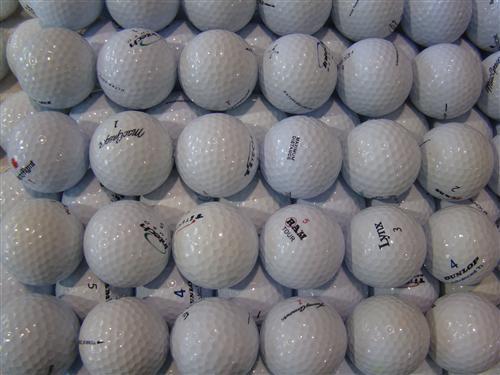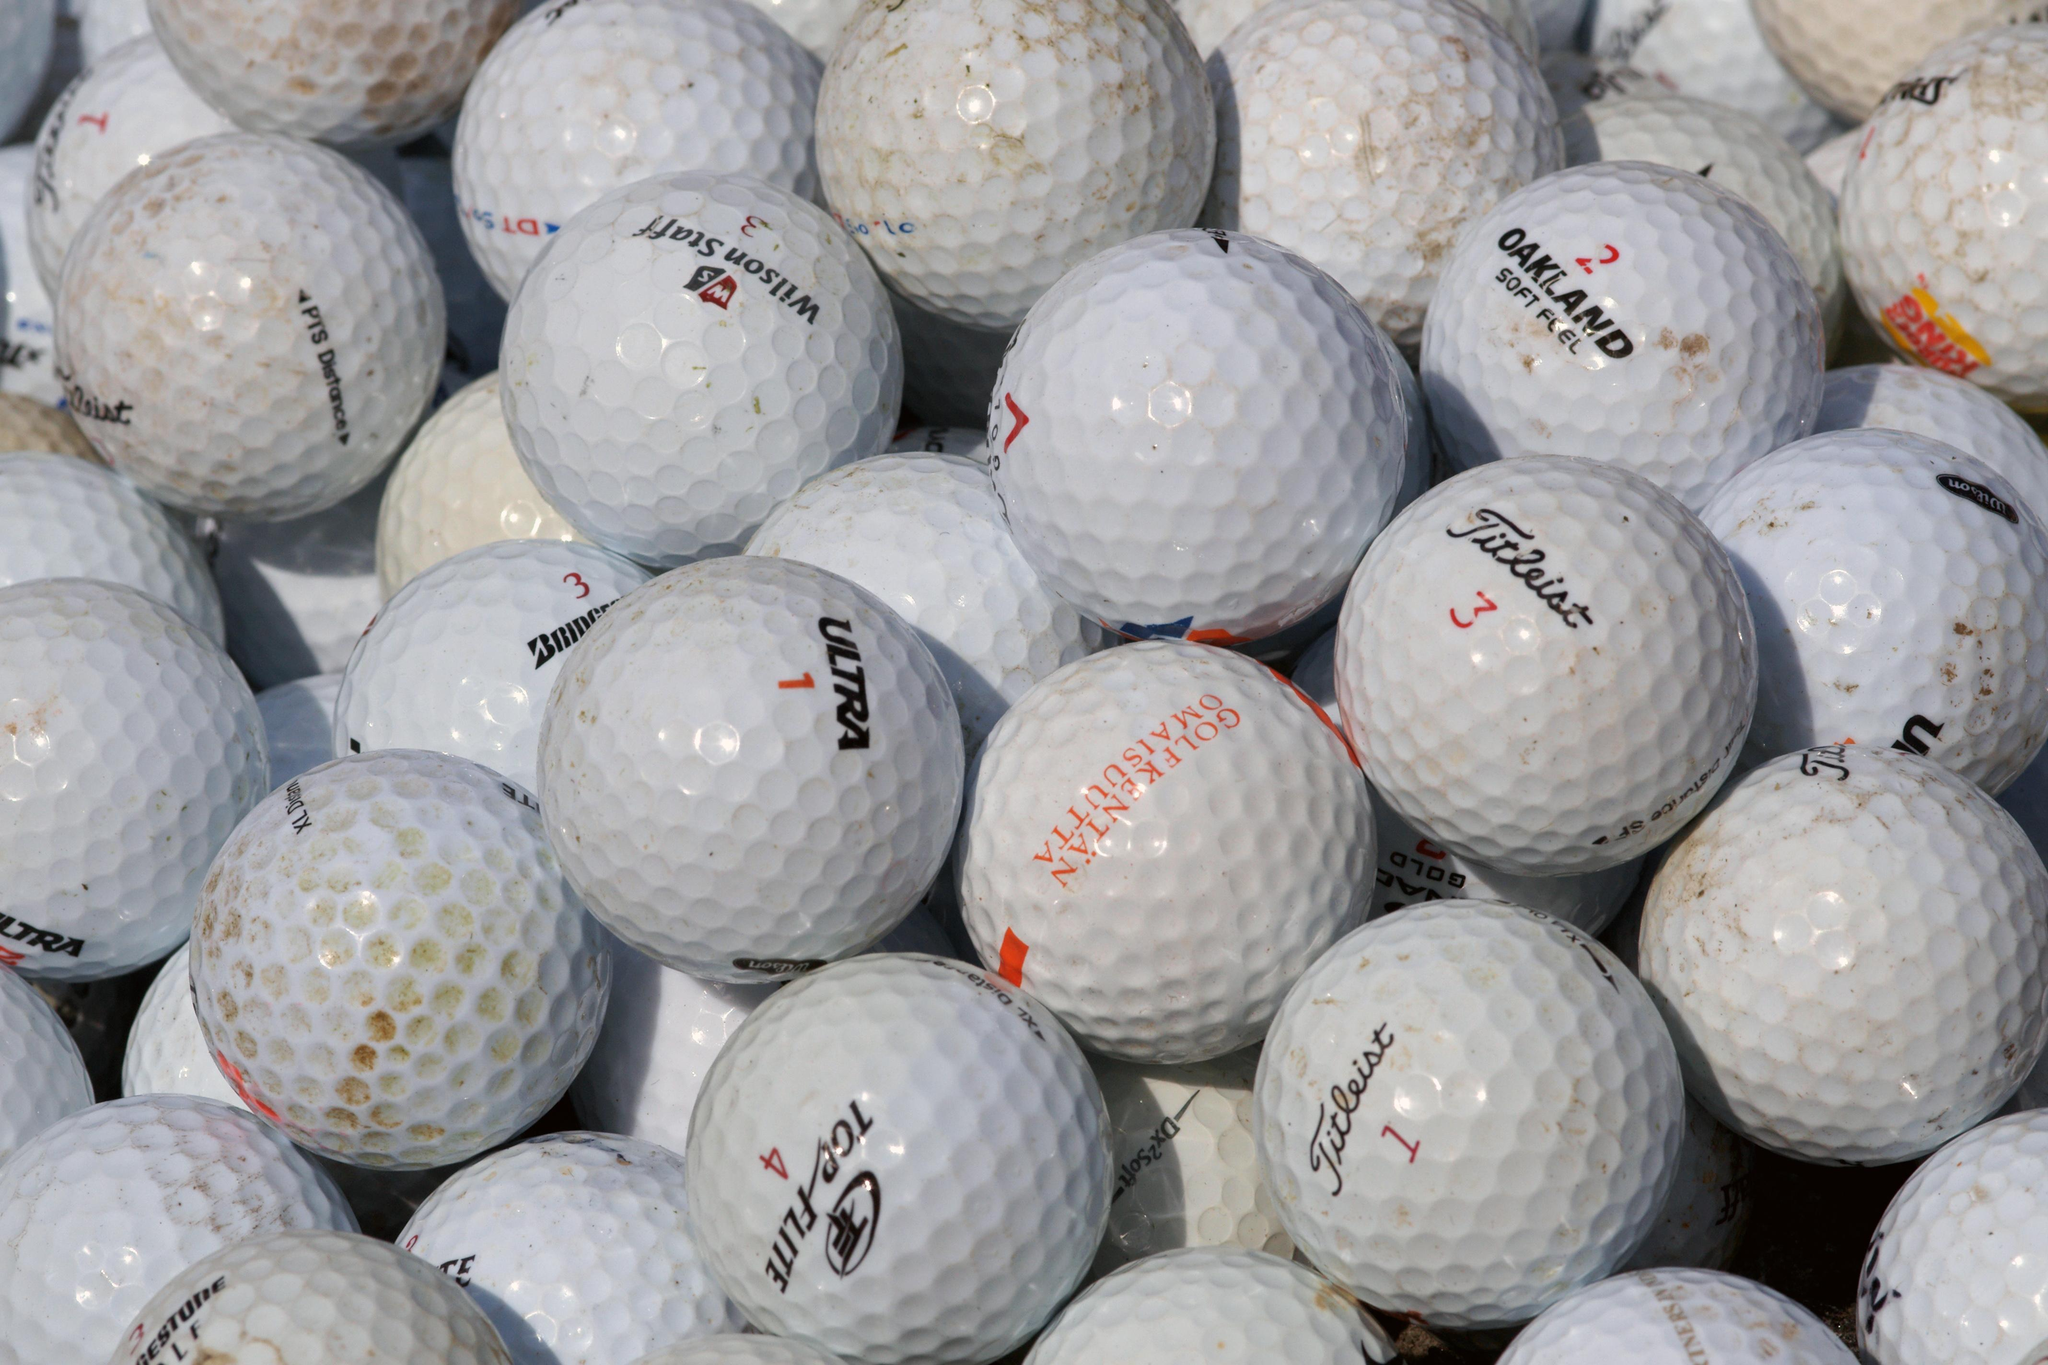The first image is the image on the left, the second image is the image on the right. For the images displayed, is the sentence "The balls in the image on the left are not in shadow" factually correct? Answer yes or no. No. The first image is the image on the left, the second image is the image on the right. For the images displayed, is the sentence "Some of the balls have an orange print" factually correct? Answer yes or no. Yes. 